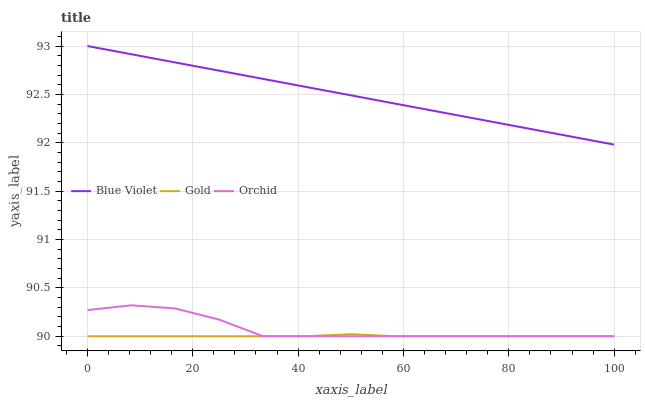Does Gold have the minimum area under the curve?
Answer yes or no. Yes. Does Blue Violet have the maximum area under the curve?
Answer yes or no. Yes. Does Orchid have the minimum area under the curve?
Answer yes or no. No. Does Orchid have the maximum area under the curve?
Answer yes or no. No. Is Blue Violet the smoothest?
Answer yes or no. Yes. Is Orchid the roughest?
Answer yes or no. Yes. Is Orchid the smoothest?
Answer yes or no. No. Is Blue Violet the roughest?
Answer yes or no. No. Does Gold have the lowest value?
Answer yes or no. Yes. Does Blue Violet have the lowest value?
Answer yes or no. No. Does Blue Violet have the highest value?
Answer yes or no. Yes. Does Orchid have the highest value?
Answer yes or no. No. Is Orchid less than Blue Violet?
Answer yes or no. Yes. Is Blue Violet greater than Gold?
Answer yes or no. Yes. Does Orchid intersect Gold?
Answer yes or no. Yes. Is Orchid less than Gold?
Answer yes or no. No. Is Orchid greater than Gold?
Answer yes or no. No. Does Orchid intersect Blue Violet?
Answer yes or no. No. 